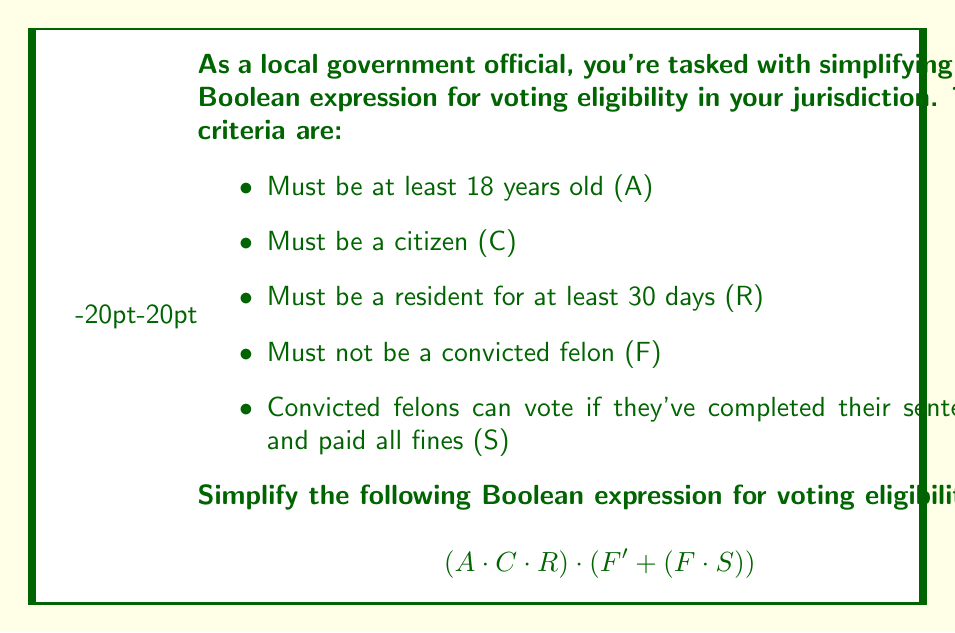Show me your answer to this math problem. Let's simplify this Boolean expression step-by-step:

1) First, let's focus on the second part of the expression: $(F' + (F \cdot S))$
   This can be simplified using the absorption law: $X + (X \cdot Y) = X + Y$
   Here, $X = F'$ and $Y = S$
   So, $(F' + (F \cdot S)) = F' + S$

2) Now our expression looks like this:
   $$(A \cdot C \cdot R) \cdot (F' + S)$$

3) We can use the distributive law to expand this:
   $$(A \cdot C \cdot R \cdot F') + (A \cdot C \cdot R \cdot S)$$

4) This expression can't be simplified further using Boolean algebra laws. However, we can interpret it logically:
   - The first term $(A \cdot C \cdot R \cdot F')$ represents eligible voters who are not felons
   - The second term $(A \cdot C \cdot R \cdot S)$ represents eligible voters who are felons but have completed their sentence and paid all fines

This final form clearly shows the two paths to voting eligibility in this jurisdiction.
Answer: $(A \cdot C \cdot R \cdot F') + (A \cdot C \cdot R \cdot S)$ 